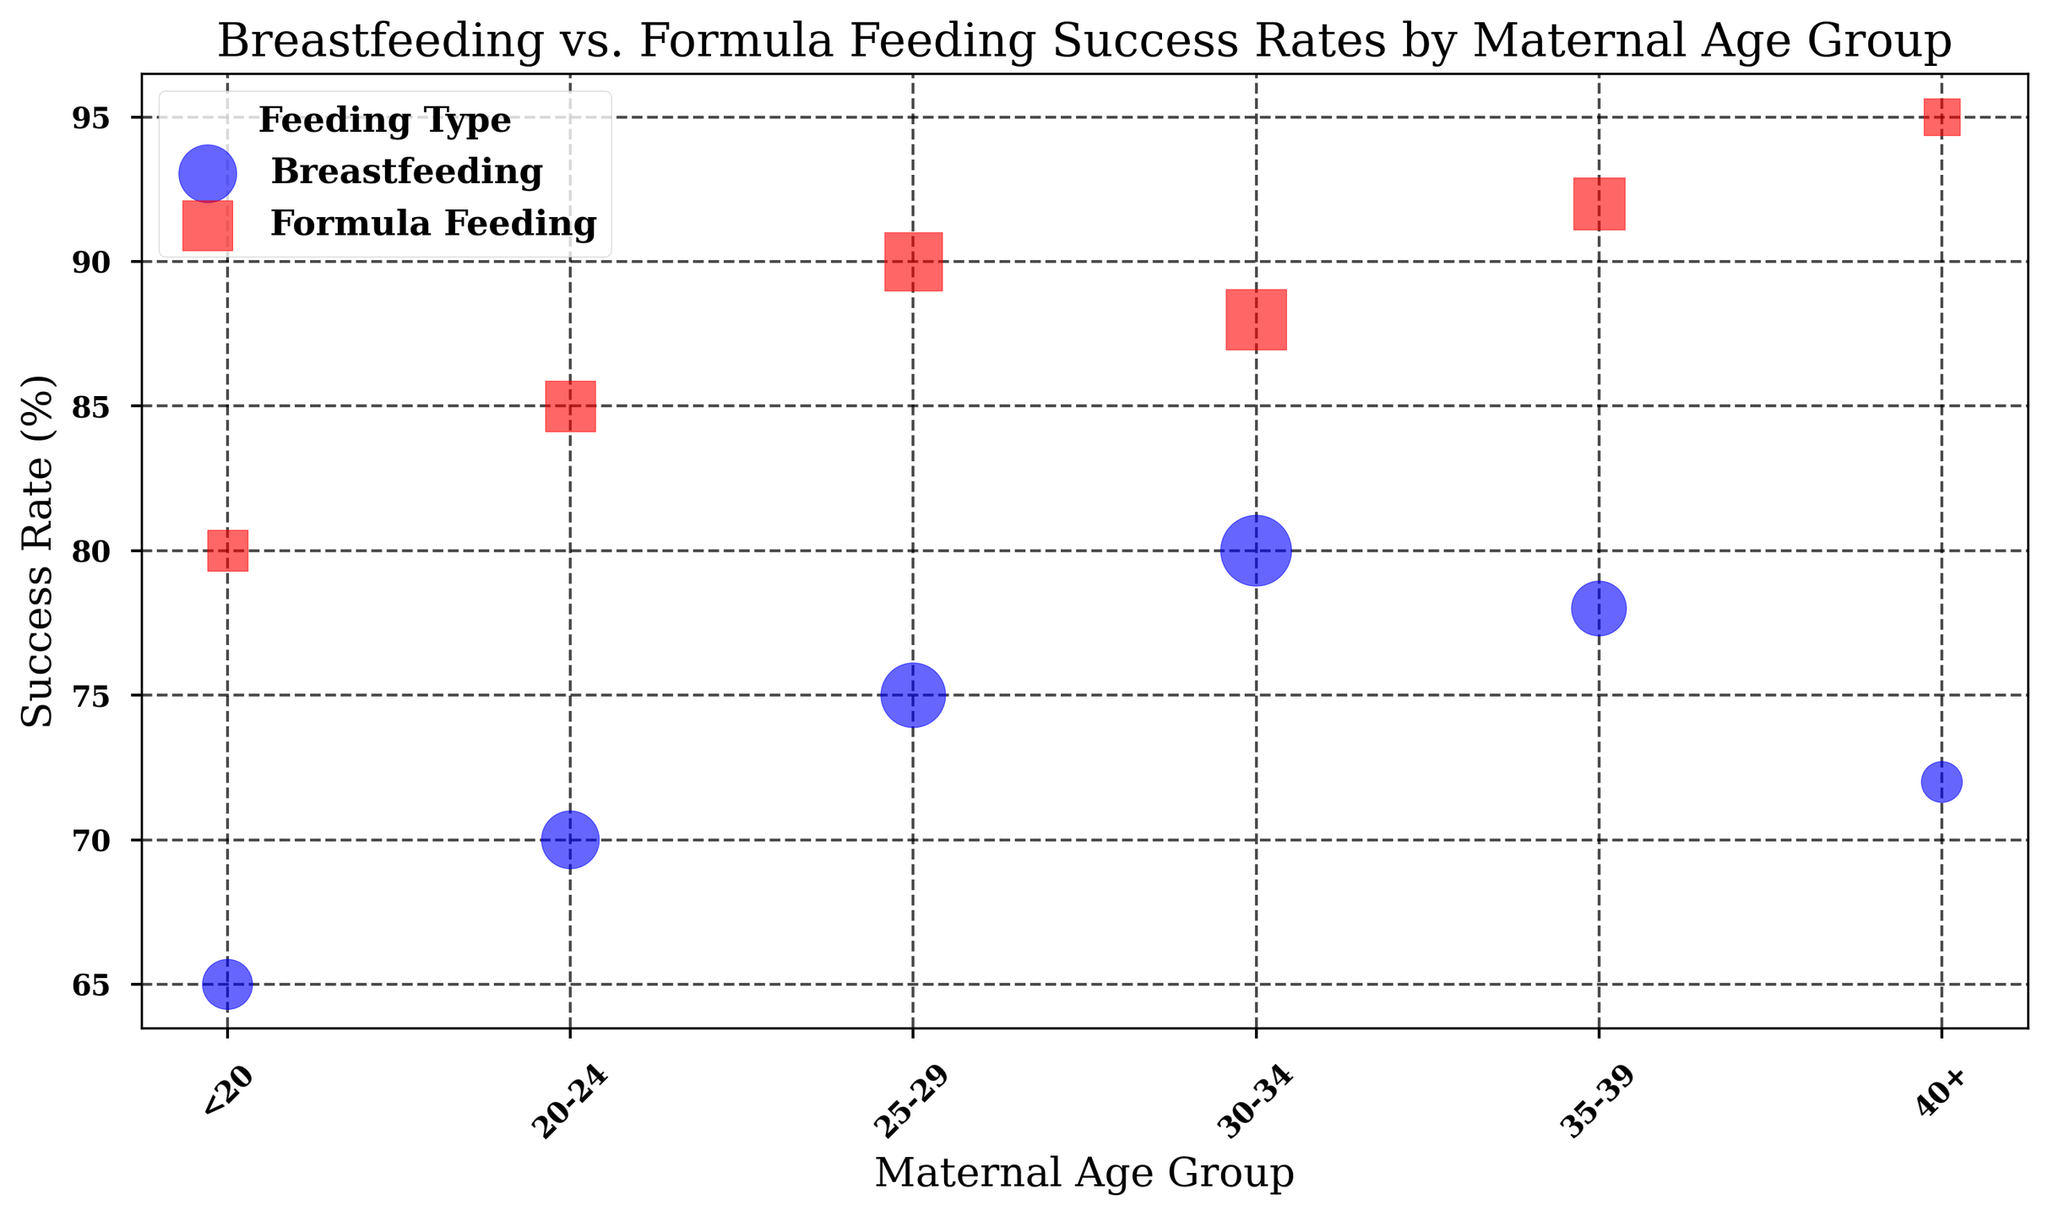Which maternal age group has the highest success rate for breastfeeding? By looking at the y-axis (Success Rate) and identifying the highest blue bubble, the age group 30-34 has the highest success rate for breastfeeding.
Answer: 30-34 Which feeding type has a higher success rate for the 35-39 age group? For the 35-39 age group, compare the heights of the blue bubble (Breastfeeding) and the red bubble (Formula Feeding). The red bubble is higher.
Answer: Formula Feeding How does the success rate of Formula Feeding for mothers aged 40+ compare to those aged 20-24? Identify the red bubbles corresponding to the 40+ and 20-24 age groups. The success rate for 40+ (95%) is higher than the success rate for 20-24 (85%).
Answer: Higher for 40+ What is the difference in success rates between Breastfeeding and Formula Feeding for the <20 age group? The success rates for Breastfeeding and Formula Feeding in the <20 age group are 65% and 80% respectively. The difference is 80% - 65% = 15%.
Answer: 15% Which maternal age group has the smallest bubble for Formula Feeding? The bubble sizes represent the number of subjects. The smallest red bubble, indicating the fewest subjects, is in the 40+ age group.
Answer: 40+ What is the sum of the success rates for Breastfeeding and Formula Feeding in the 25-29 age group? The success rates for 25-29 are 75% (Breastfeeding) and 90% (Formula Feeding). Summing them gives 75 + 90 = 165.
Answer: 165 Which feeding type shows a steadier increase in success rates as maternal age increases? By observing the consistency in the heights of the blue and red bubbles, Formula Feeding shows a more consistent and smoother increase compared to Breastfeeding.
Answer: Formula Feeding What is the percentage difference between the breastfeeding success rates for the 20-24 and 30-34 age groups? The success rates for Breastfeeding in the 20-24 and 30-34 age groups are 70% and 80% respectively. The percentage difference is (80 - 70) / 70 * 100 = 14.3%.
Answer: 14.3% In which maternal age group is the difference between breastfeeding and formula feeding success rates the greatest? Compare the height difference between blue and red bubbles for each age group. The greatest difference is in the <20 age group (80% - 65% = 15%).
Answer: <20 